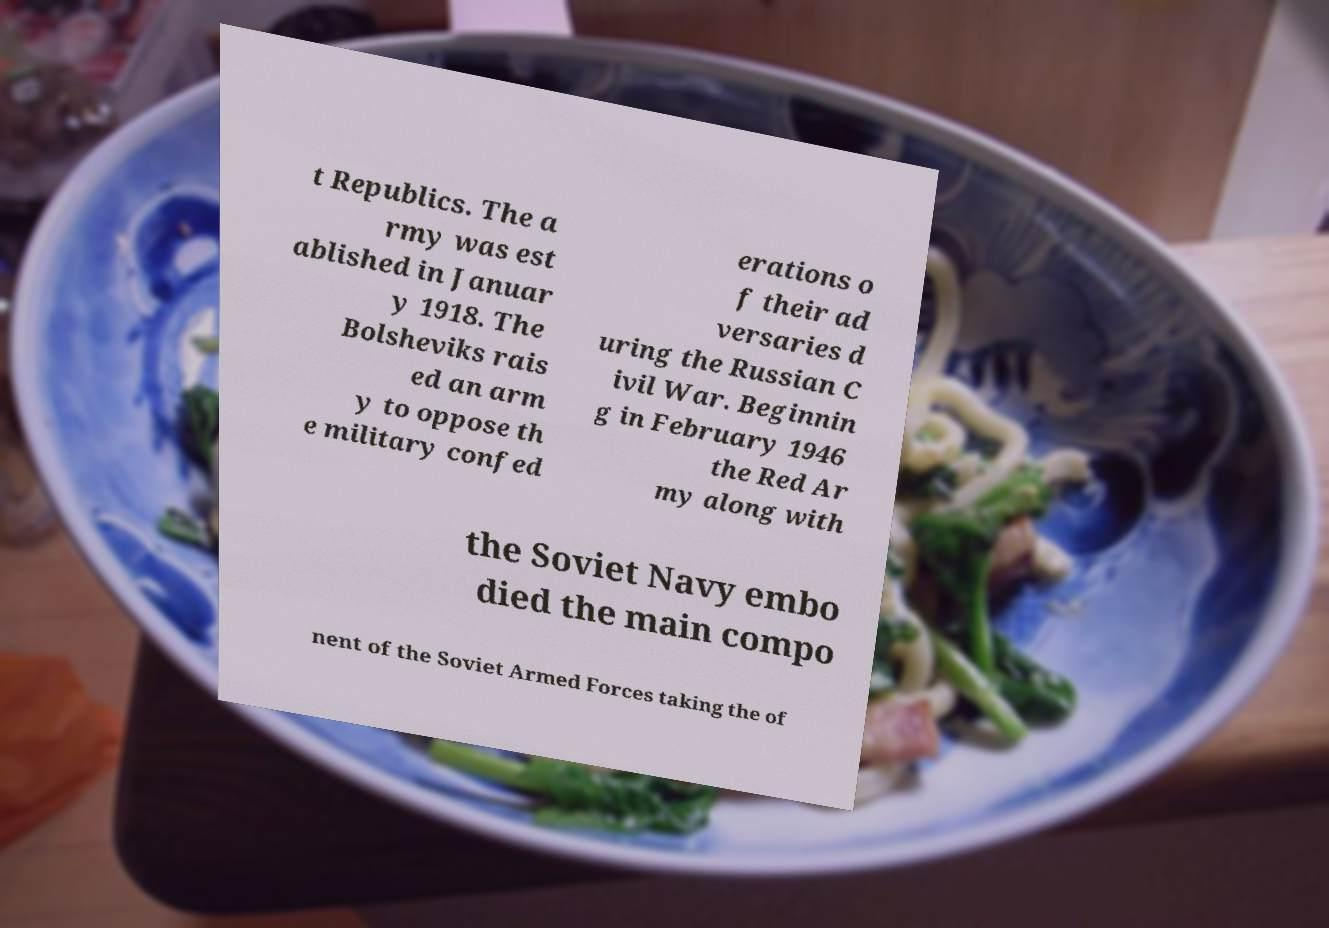What messages or text are displayed in this image? I need them in a readable, typed format. t Republics. The a rmy was est ablished in Januar y 1918. The Bolsheviks rais ed an arm y to oppose th e military confed erations o f their ad versaries d uring the Russian C ivil War. Beginnin g in February 1946 the Red Ar my along with the Soviet Navy embo died the main compo nent of the Soviet Armed Forces taking the of 